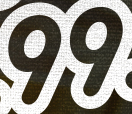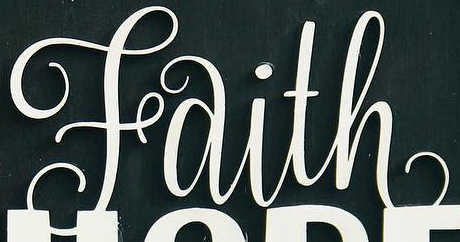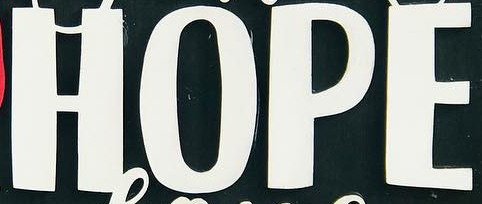Read the text content from these images in order, separated by a semicolon. 99; Faith; HOPE 